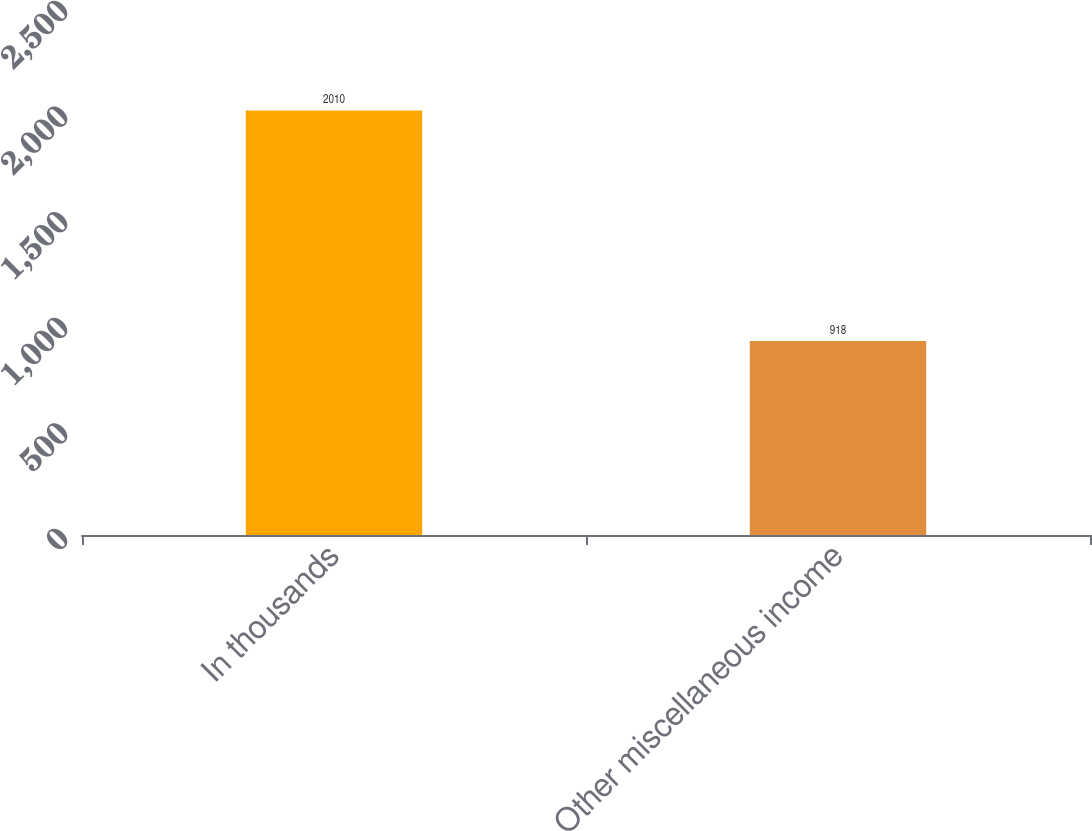Convert chart to OTSL. <chart><loc_0><loc_0><loc_500><loc_500><bar_chart><fcel>In thousands<fcel>Other miscellaneous income<nl><fcel>2010<fcel>918<nl></chart> 